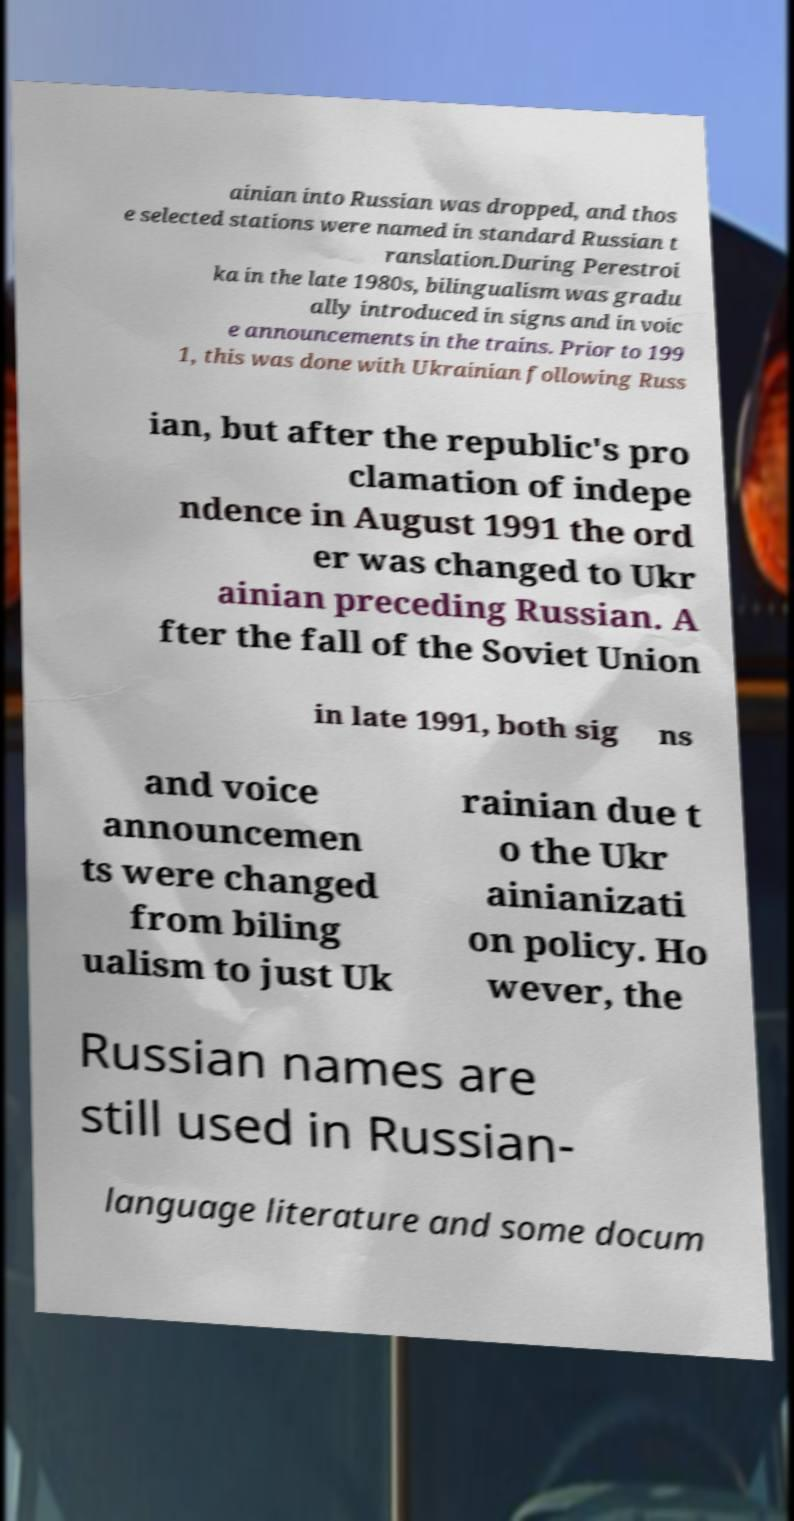Please read and relay the text visible in this image. What does it say? ainian into Russian was dropped, and thos e selected stations were named in standard Russian t ranslation.During Perestroi ka in the late 1980s, bilingualism was gradu ally introduced in signs and in voic e announcements in the trains. Prior to 199 1, this was done with Ukrainian following Russ ian, but after the republic's pro clamation of indepe ndence in August 1991 the ord er was changed to Ukr ainian preceding Russian. A fter the fall of the Soviet Union in late 1991, both sig ns and voice announcemen ts were changed from biling ualism to just Uk rainian due t o the Ukr ainianizati on policy. Ho wever, the Russian names are still used in Russian- language literature and some docum 